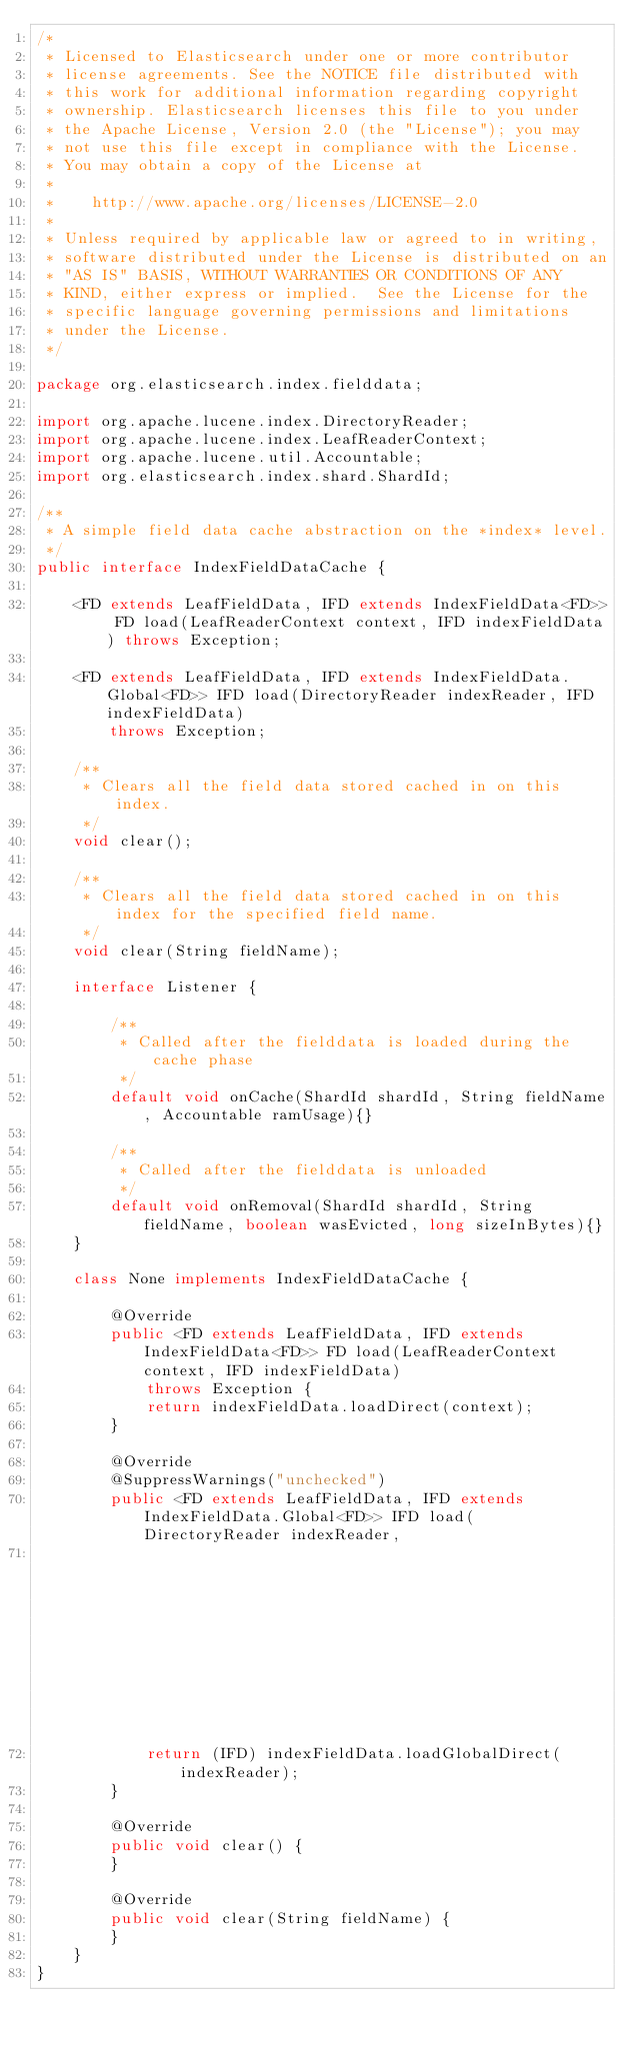Convert code to text. <code><loc_0><loc_0><loc_500><loc_500><_Java_>/*
 * Licensed to Elasticsearch under one or more contributor
 * license agreements. See the NOTICE file distributed with
 * this work for additional information regarding copyright
 * ownership. Elasticsearch licenses this file to you under
 * the Apache License, Version 2.0 (the "License"); you may
 * not use this file except in compliance with the License.
 * You may obtain a copy of the License at
 *
 *    http://www.apache.org/licenses/LICENSE-2.0
 *
 * Unless required by applicable law or agreed to in writing,
 * software distributed under the License is distributed on an
 * "AS IS" BASIS, WITHOUT WARRANTIES OR CONDITIONS OF ANY
 * KIND, either express or implied.  See the License for the
 * specific language governing permissions and limitations
 * under the License.
 */

package org.elasticsearch.index.fielddata;

import org.apache.lucene.index.DirectoryReader;
import org.apache.lucene.index.LeafReaderContext;
import org.apache.lucene.util.Accountable;
import org.elasticsearch.index.shard.ShardId;

/**
 * A simple field data cache abstraction on the *index* level.
 */
public interface IndexFieldDataCache {

    <FD extends LeafFieldData, IFD extends IndexFieldData<FD>> FD load(LeafReaderContext context, IFD indexFieldData) throws Exception;

    <FD extends LeafFieldData, IFD extends IndexFieldData.Global<FD>> IFD load(DirectoryReader indexReader, IFD indexFieldData)
        throws Exception;

    /**
     * Clears all the field data stored cached in on this index.
     */
    void clear();

    /**
     * Clears all the field data stored cached in on this index for the specified field name.
     */
    void clear(String fieldName);

    interface Listener {

        /**
         * Called after the fielddata is loaded during the cache phase
         */
        default void onCache(ShardId shardId, String fieldName, Accountable ramUsage){}

        /**
         * Called after the fielddata is unloaded
         */
        default void onRemoval(ShardId shardId, String fieldName, boolean wasEvicted, long sizeInBytes){}
    }

    class None implements IndexFieldDataCache {

        @Override
        public <FD extends LeafFieldData, IFD extends IndexFieldData<FD>> FD load(LeafReaderContext context, IFD indexFieldData)
            throws Exception {
            return indexFieldData.loadDirect(context);
        }

        @Override
        @SuppressWarnings("unchecked")
        public <FD extends LeafFieldData, IFD extends IndexFieldData.Global<FD>> IFD load(DirectoryReader indexReader,
                                                                                          IFD indexFieldData) throws Exception {
            return (IFD) indexFieldData.loadGlobalDirect(indexReader);
        }

        @Override
        public void clear() {
        }

        @Override
        public void clear(String fieldName) {
        }
    }
}
</code> 